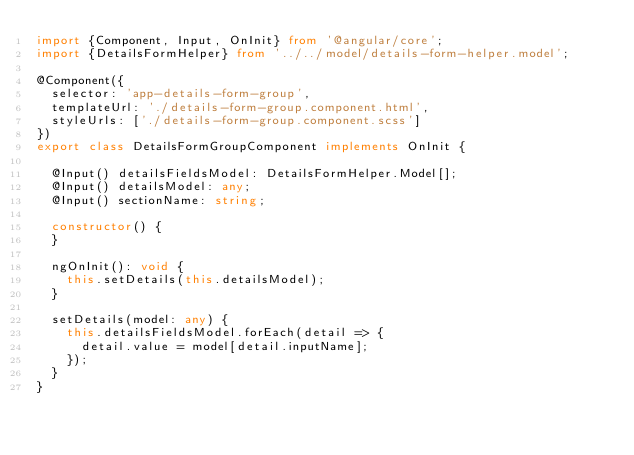Convert code to text. <code><loc_0><loc_0><loc_500><loc_500><_TypeScript_>import {Component, Input, OnInit} from '@angular/core';
import {DetailsFormHelper} from '../../model/details-form-helper.model';

@Component({
  selector: 'app-details-form-group',
  templateUrl: './details-form-group.component.html',
  styleUrls: ['./details-form-group.component.scss']
})
export class DetailsFormGroupComponent implements OnInit {

  @Input() detailsFieldsModel: DetailsFormHelper.Model[];
  @Input() detailsModel: any;
  @Input() sectionName: string;

  constructor() {
  }

  ngOnInit(): void {
    this.setDetails(this.detailsModel);
  }

  setDetails(model: any) {
    this.detailsFieldsModel.forEach(detail => {
      detail.value = model[detail.inputName];
    });
  }
}
</code> 